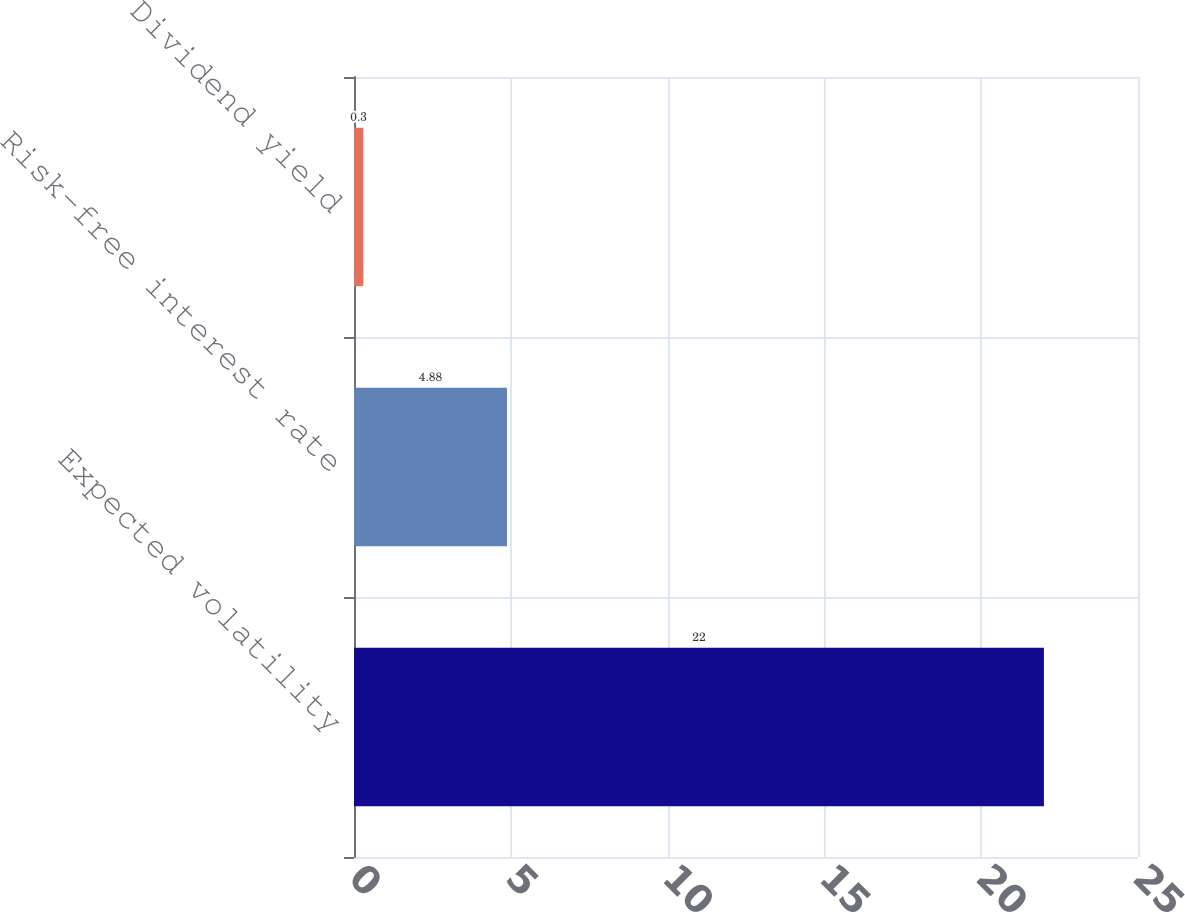Convert chart to OTSL. <chart><loc_0><loc_0><loc_500><loc_500><bar_chart><fcel>Expected volatility<fcel>Risk-free interest rate<fcel>Dividend yield<nl><fcel>22<fcel>4.88<fcel>0.3<nl></chart> 